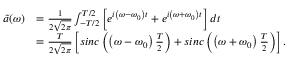Convert formula to latex. <formula><loc_0><loc_0><loc_500><loc_500>\begin{array} { r l } { \tilde { a } ( \omega ) } & { = \frac { 1 } { 2 \sqrt { 2 \pi } } \int _ { - T / 2 } ^ { T / 2 } \left [ e ^ { i \left ( \omega - \omega _ { 0 } \right ) t } + e ^ { i \left ( \omega + \omega _ { 0 } \right ) t } \right ] d t \, } \\ & { = \frac { T } { 2 \sqrt { 2 \pi } } \left [ \sin c \left ( \left ( \omega - \omega _ { 0 } \right ) \frac { T } { 2 } \right ) + \sin c \left ( \left ( \omega + \omega _ { 0 } \right ) \frac { T } { 2 } \right ) \right ] . } \end{array}</formula> 